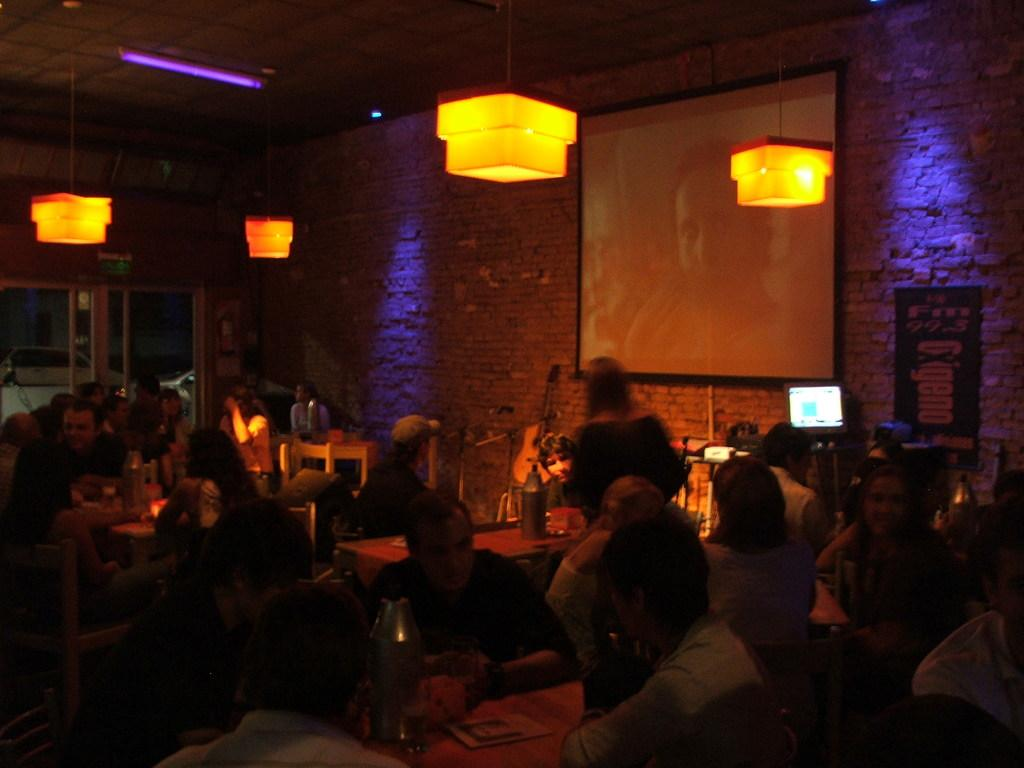How many people are in the image? There is a group of people in the image, but the exact number is not specified. What are the people in the image doing? Some people are sitting, while others are standing. What can be seen on the screen in the image? The facts do not specify what is on the screen. What can be seen in the background of the image? There are lights in the background of the image. What type of loaf is being used as a seat by one of the people in the image? There is no loaf present in the image; people are either sitting or standing on regular seats or the ground. What color is the string tied around the neck of the person in the image? There is no string tied around anyone's neck in the image. 